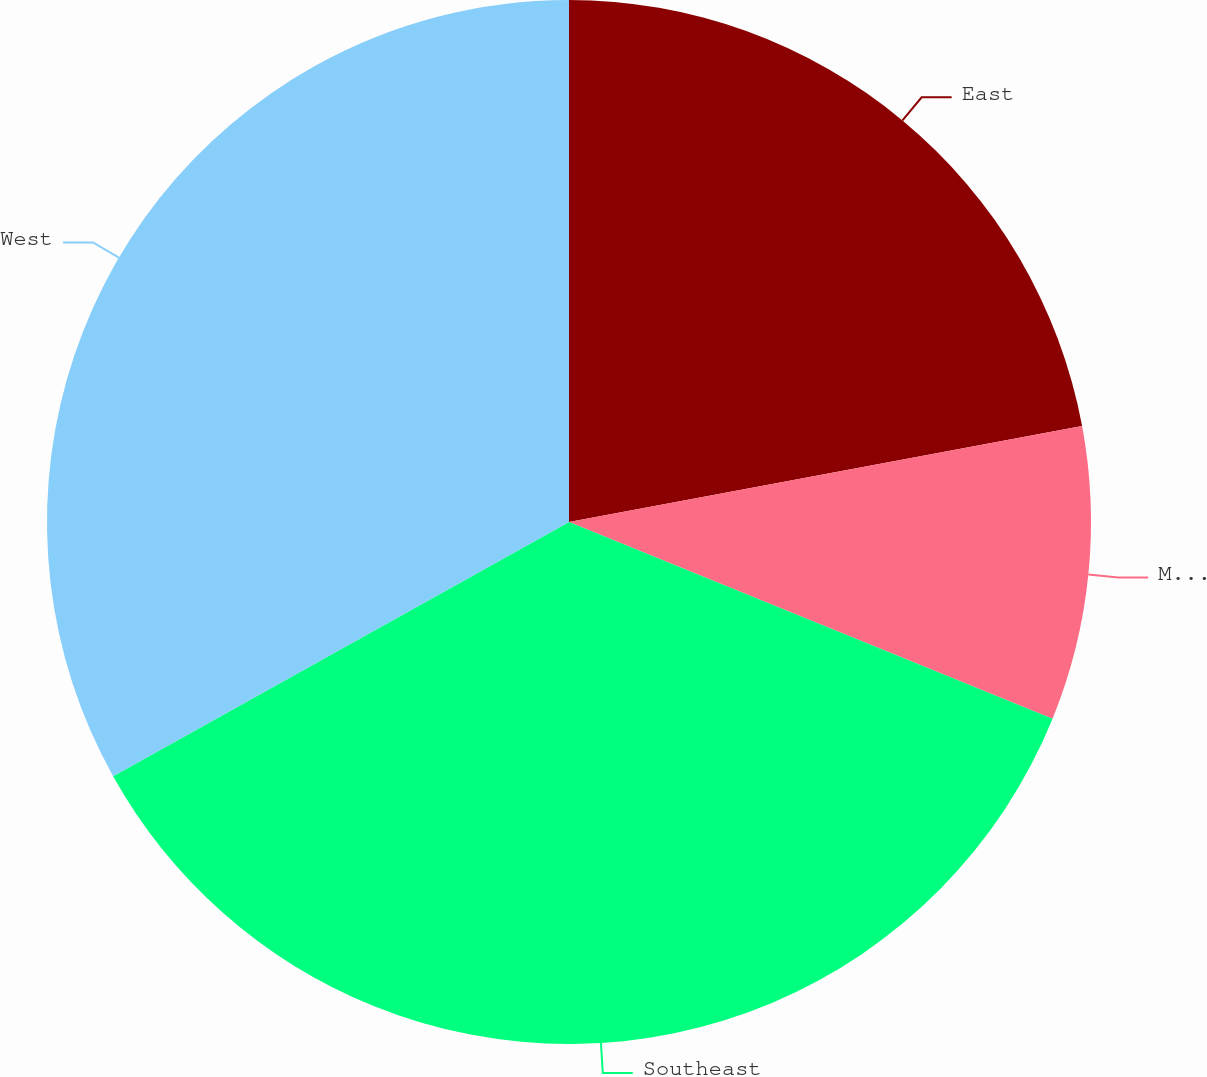Convert chart. <chart><loc_0><loc_0><loc_500><loc_500><pie_chart><fcel>East<fcel>Midwest<fcel>Southeast<fcel>West<nl><fcel>22.06%<fcel>9.09%<fcel>35.76%<fcel>33.1%<nl></chart> 